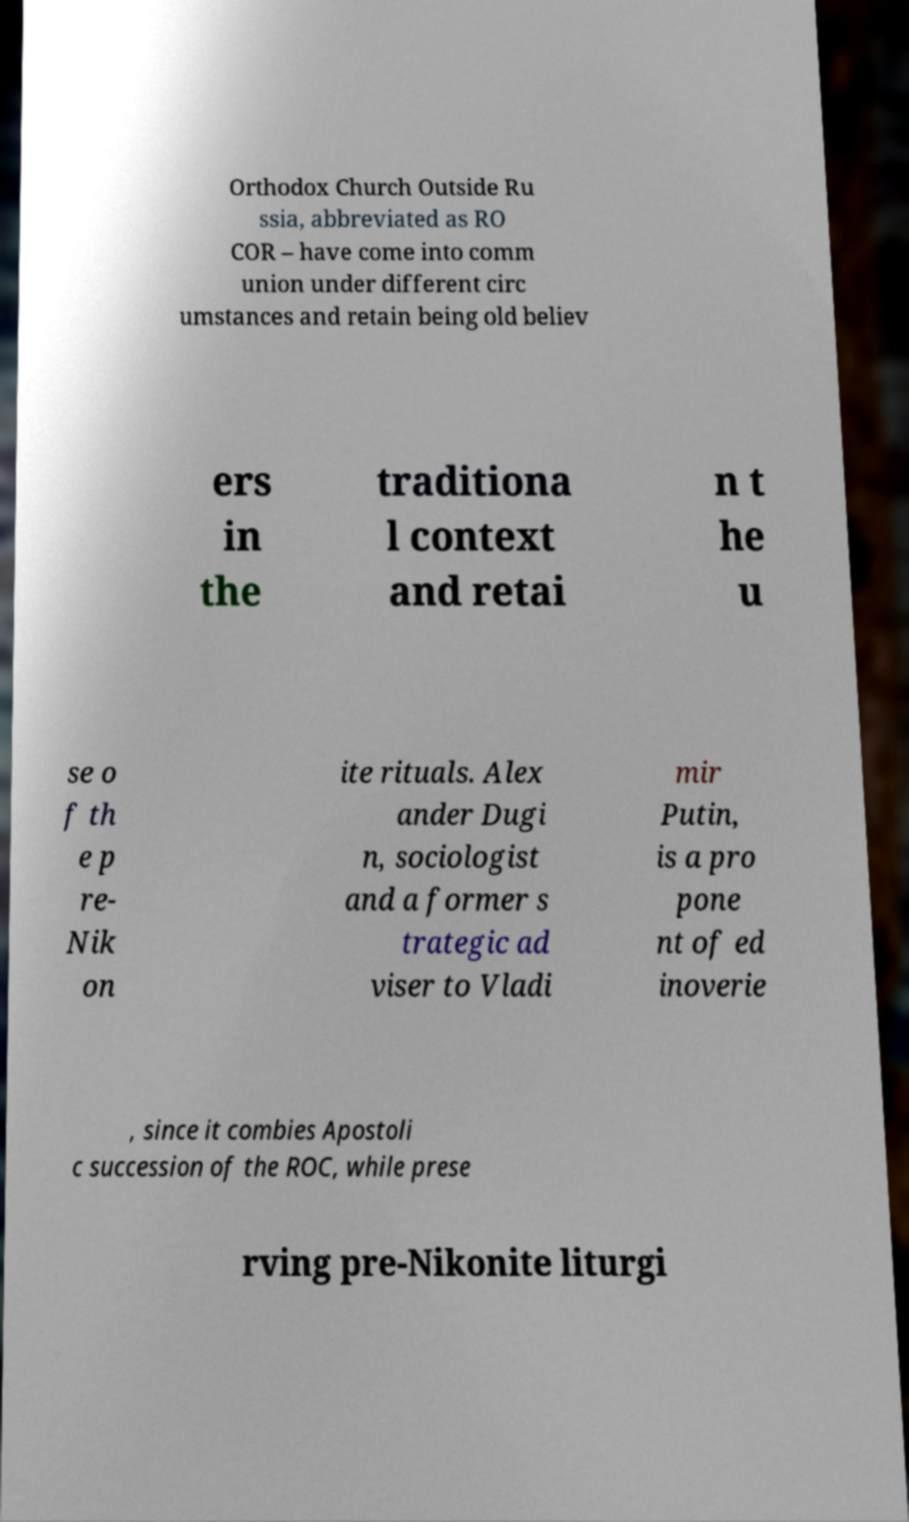For documentation purposes, I need the text within this image transcribed. Could you provide that? Orthodox Church Outside Ru ssia, abbreviated as RO COR – have come into comm union under different circ umstances and retain being old believ ers in the traditiona l context and retai n t he u se o f th e p re- Nik on ite rituals. Alex ander Dugi n, sociologist and a former s trategic ad viser to Vladi mir Putin, is a pro pone nt of ed inoverie , since it combies Apostoli c succession of the ROC, while prese rving pre-Nikonite liturgi 